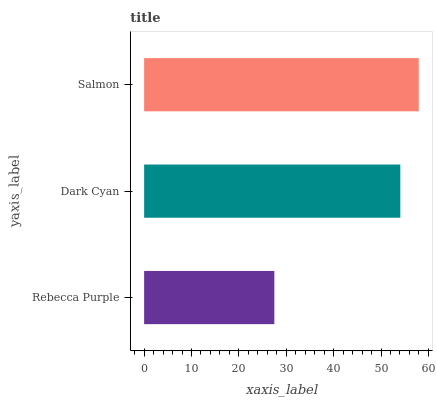Is Rebecca Purple the minimum?
Answer yes or no. Yes. Is Salmon the maximum?
Answer yes or no. Yes. Is Dark Cyan the minimum?
Answer yes or no. No. Is Dark Cyan the maximum?
Answer yes or no. No. Is Dark Cyan greater than Rebecca Purple?
Answer yes or no. Yes. Is Rebecca Purple less than Dark Cyan?
Answer yes or no. Yes. Is Rebecca Purple greater than Dark Cyan?
Answer yes or no. No. Is Dark Cyan less than Rebecca Purple?
Answer yes or no. No. Is Dark Cyan the high median?
Answer yes or no. Yes. Is Dark Cyan the low median?
Answer yes or no. Yes. Is Salmon the high median?
Answer yes or no. No. Is Salmon the low median?
Answer yes or no. No. 